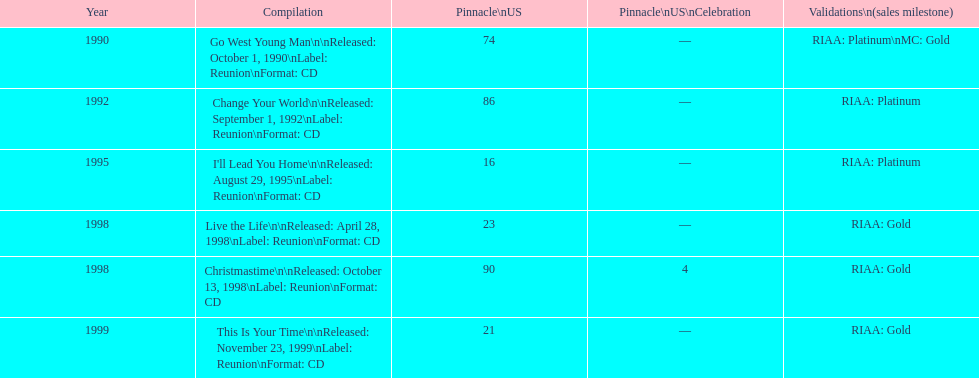What michael w smith album was released before his christmastime album? Live the Life. 